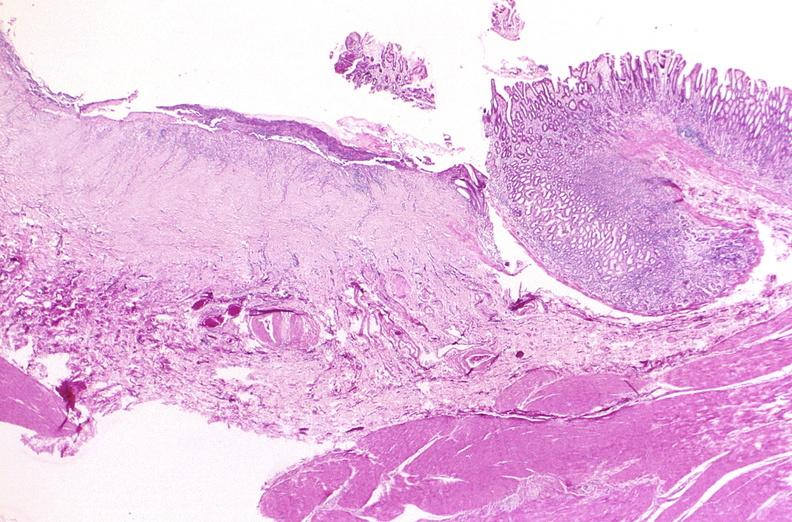s female reproductive present?
Answer the question using a single word or phrase. No 